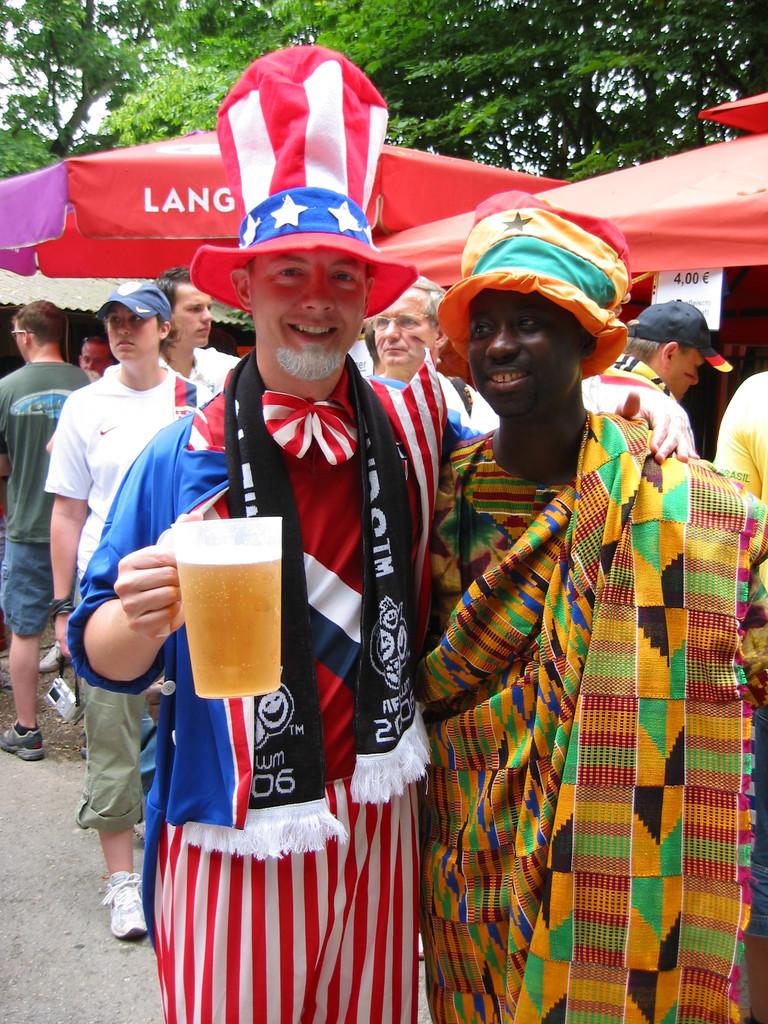What is written on the umbrella next to uncle sam's hat?
Your response must be concise. Lang. What number is on uncle sam's scarf on the bottom?
Provide a succinct answer. 06. 